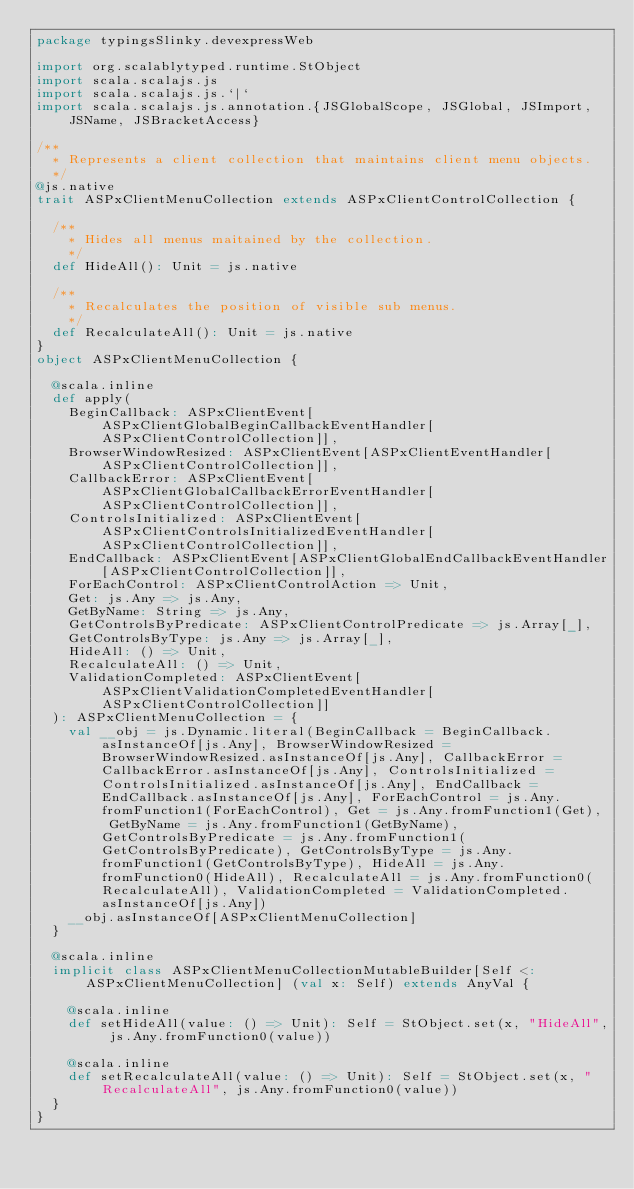<code> <loc_0><loc_0><loc_500><loc_500><_Scala_>package typingsSlinky.devexpressWeb

import org.scalablytyped.runtime.StObject
import scala.scalajs.js
import scala.scalajs.js.`|`
import scala.scalajs.js.annotation.{JSGlobalScope, JSGlobal, JSImport, JSName, JSBracketAccess}

/**
  * Represents a client collection that maintains client menu objects.
  */
@js.native
trait ASPxClientMenuCollection extends ASPxClientControlCollection {
  
  /**
    * Hides all menus maitained by the collection.
    */
  def HideAll(): Unit = js.native
  
  /**
    * Recalculates the position of visible sub menus.
    */
  def RecalculateAll(): Unit = js.native
}
object ASPxClientMenuCollection {
  
  @scala.inline
  def apply(
    BeginCallback: ASPxClientEvent[ASPxClientGlobalBeginCallbackEventHandler[ASPxClientControlCollection]],
    BrowserWindowResized: ASPxClientEvent[ASPxClientEventHandler[ASPxClientControlCollection]],
    CallbackError: ASPxClientEvent[ASPxClientGlobalCallbackErrorEventHandler[ASPxClientControlCollection]],
    ControlsInitialized: ASPxClientEvent[ASPxClientControlsInitializedEventHandler[ASPxClientControlCollection]],
    EndCallback: ASPxClientEvent[ASPxClientGlobalEndCallbackEventHandler[ASPxClientControlCollection]],
    ForEachControl: ASPxClientControlAction => Unit,
    Get: js.Any => js.Any,
    GetByName: String => js.Any,
    GetControlsByPredicate: ASPxClientControlPredicate => js.Array[_],
    GetControlsByType: js.Any => js.Array[_],
    HideAll: () => Unit,
    RecalculateAll: () => Unit,
    ValidationCompleted: ASPxClientEvent[ASPxClientValidationCompletedEventHandler[ASPxClientControlCollection]]
  ): ASPxClientMenuCollection = {
    val __obj = js.Dynamic.literal(BeginCallback = BeginCallback.asInstanceOf[js.Any], BrowserWindowResized = BrowserWindowResized.asInstanceOf[js.Any], CallbackError = CallbackError.asInstanceOf[js.Any], ControlsInitialized = ControlsInitialized.asInstanceOf[js.Any], EndCallback = EndCallback.asInstanceOf[js.Any], ForEachControl = js.Any.fromFunction1(ForEachControl), Get = js.Any.fromFunction1(Get), GetByName = js.Any.fromFunction1(GetByName), GetControlsByPredicate = js.Any.fromFunction1(GetControlsByPredicate), GetControlsByType = js.Any.fromFunction1(GetControlsByType), HideAll = js.Any.fromFunction0(HideAll), RecalculateAll = js.Any.fromFunction0(RecalculateAll), ValidationCompleted = ValidationCompleted.asInstanceOf[js.Any])
    __obj.asInstanceOf[ASPxClientMenuCollection]
  }
  
  @scala.inline
  implicit class ASPxClientMenuCollectionMutableBuilder[Self <: ASPxClientMenuCollection] (val x: Self) extends AnyVal {
    
    @scala.inline
    def setHideAll(value: () => Unit): Self = StObject.set(x, "HideAll", js.Any.fromFunction0(value))
    
    @scala.inline
    def setRecalculateAll(value: () => Unit): Self = StObject.set(x, "RecalculateAll", js.Any.fromFunction0(value))
  }
}
</code> 